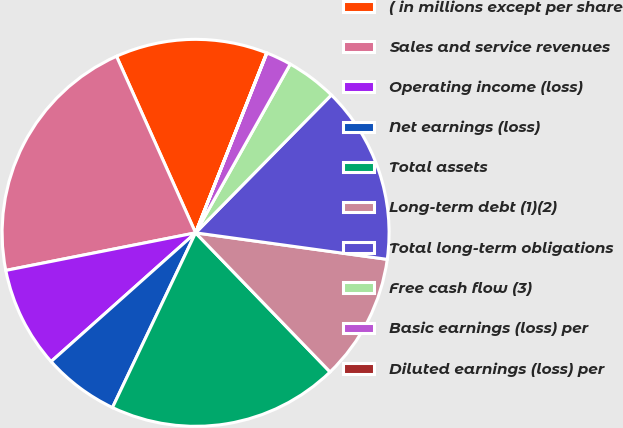Convert chart. <chart><loc_0><loc_0><loc_500><loc_500><pie_chart><fcel>( in millions except per share<fcel>Sales and service revenues<fcel>Operating income (loss)<fcel>Net earnings (loss)<fcel>Total assets<fcel>Long-term debt (1)(2)<fcel>Total long-term obligations<fcel>Free cash flow (3)<fcel>Basic earnings (loss) per<fcel>Diluted earnings (loss) per<nl><fcel>12.69%<fcel>21.41%<fcel>8.47%<fcel>6.35%<fcel>19.3%<fcel>10.58%<fcel>14.81%<fcel>4.24%<fcel>2.13%<fcel>0.02%<nl></chart> 